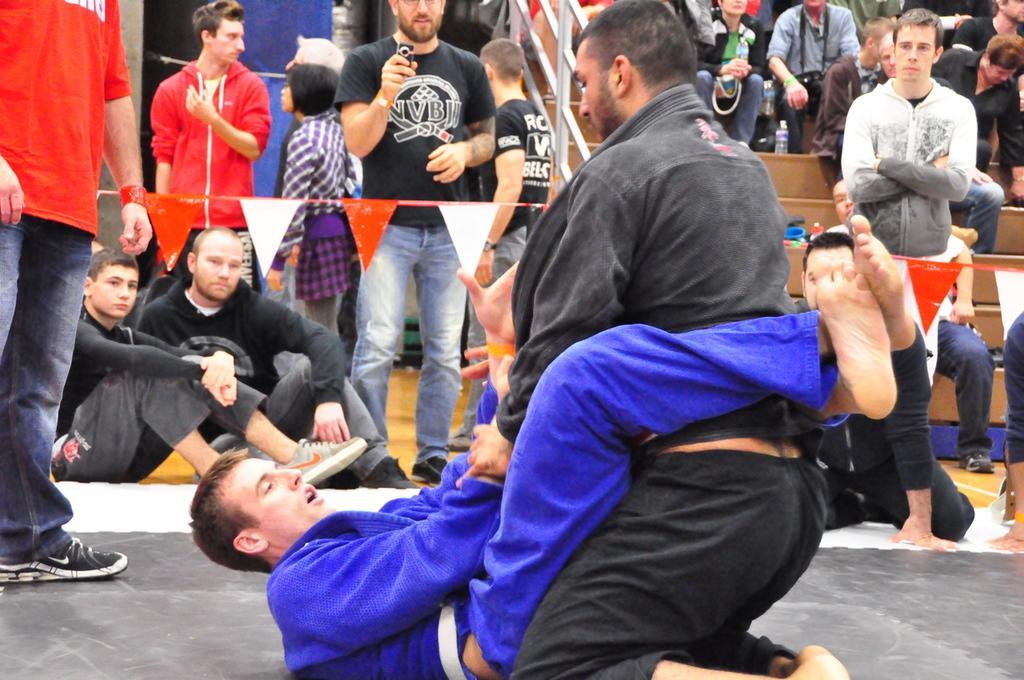Could you give a brief overview of what you see in this image? In this picture I can see two persons are wrestling in the middle, on the left side few persons are standing and looking at them. On the right side a group of people are sitting. 